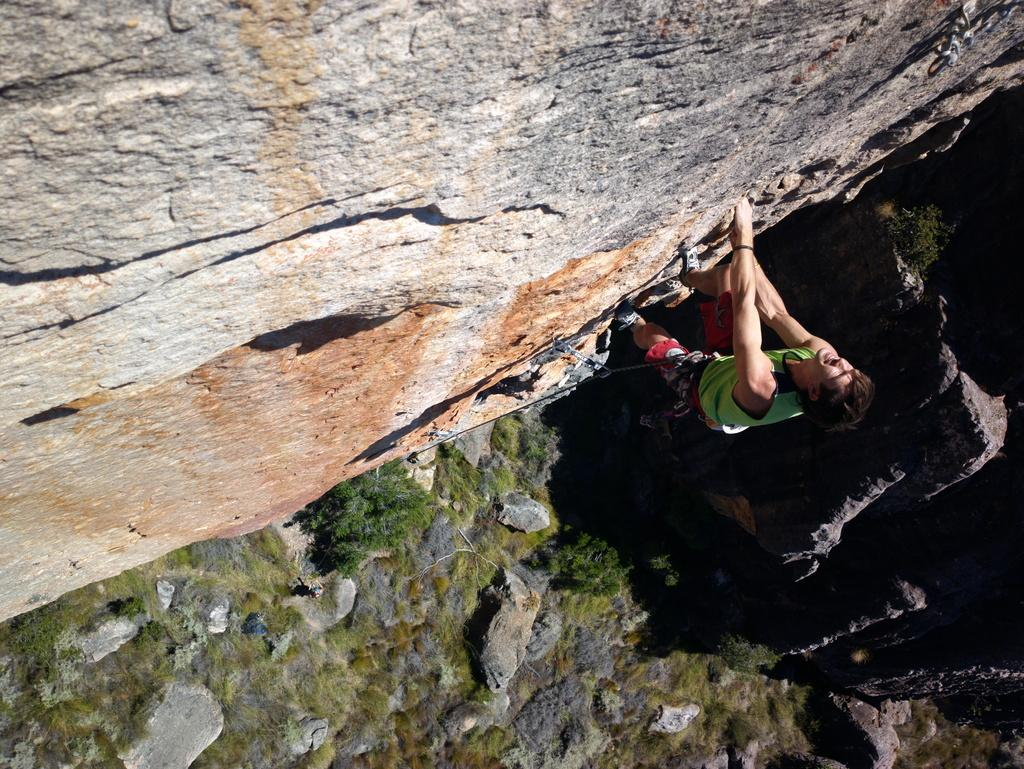What is the person in the image doing? There is a person climbing a hill in the image. What can be seen at the bottom of the hill? Plants, stones, and grass are present at the bottom of the image. What type of yarn is the person using to climb the hill in the image? There is no yarn present in the image; the person is climbing the hill without any visible assistance. 